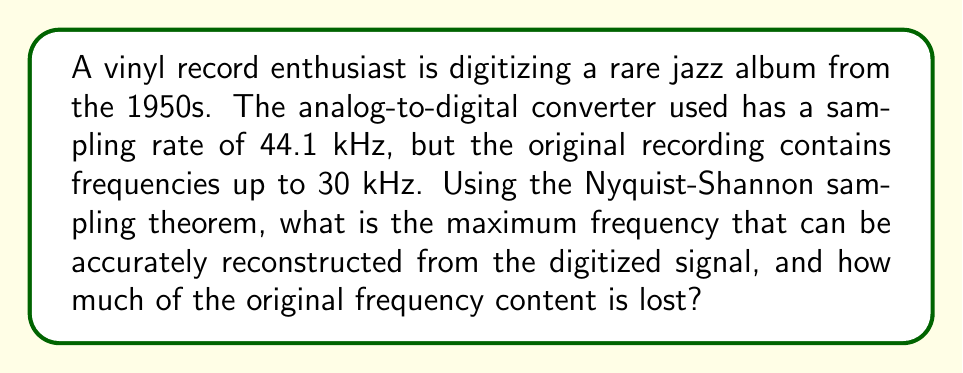Can you solve this math problem? To solve this problem, we'll use the Nyquist-Shannon sampling theorem and follow these steps:

1. Recall the Nyquist-Shannon sampling theorem:
   The maximum frequency that can be accurately reconstructed from a digitized signal is half the sampling rate. This is called the Nyquist frequency.

2. Calculate the Nyquist frequency:
   $$f_{Nyquist} = \frac{f_{sampling}}{2}$$
   $$f_{Nyquist} = \frac{44.1 \text{ kHz}}{2} = 22.05 \text{ kHz}$$

3. Compare the Nyquist frequency to the original signal's maximum frequency:
   - Nyquist frequency: 22.05 kHz
   - Original signal's maximum frequency: 30 kHz

4. Calculate the lost frequency content:
   $$f_{lost} = f_{original\_max} - f_{Nyquist}$$
   $$f_{lost} = 30 \text{ kHz} - 22.05 \text{ kHz} = 7.95 \text{ kHz}$$

5. Express the lost content as a percentage of the original frequency range:
   $$\text{Percentage lost} = \frac{f_{lost}}{f_{original\_max}} \times 100\%$$
   $$\text{Percentage lost} = \frac{7.95 \text{ kHz}}{30 \text{ kHz}} \times 100\% \approx 26.5\%$$
Answer: 22.05 kHz; 7.95 kHz (26.5%) lost 